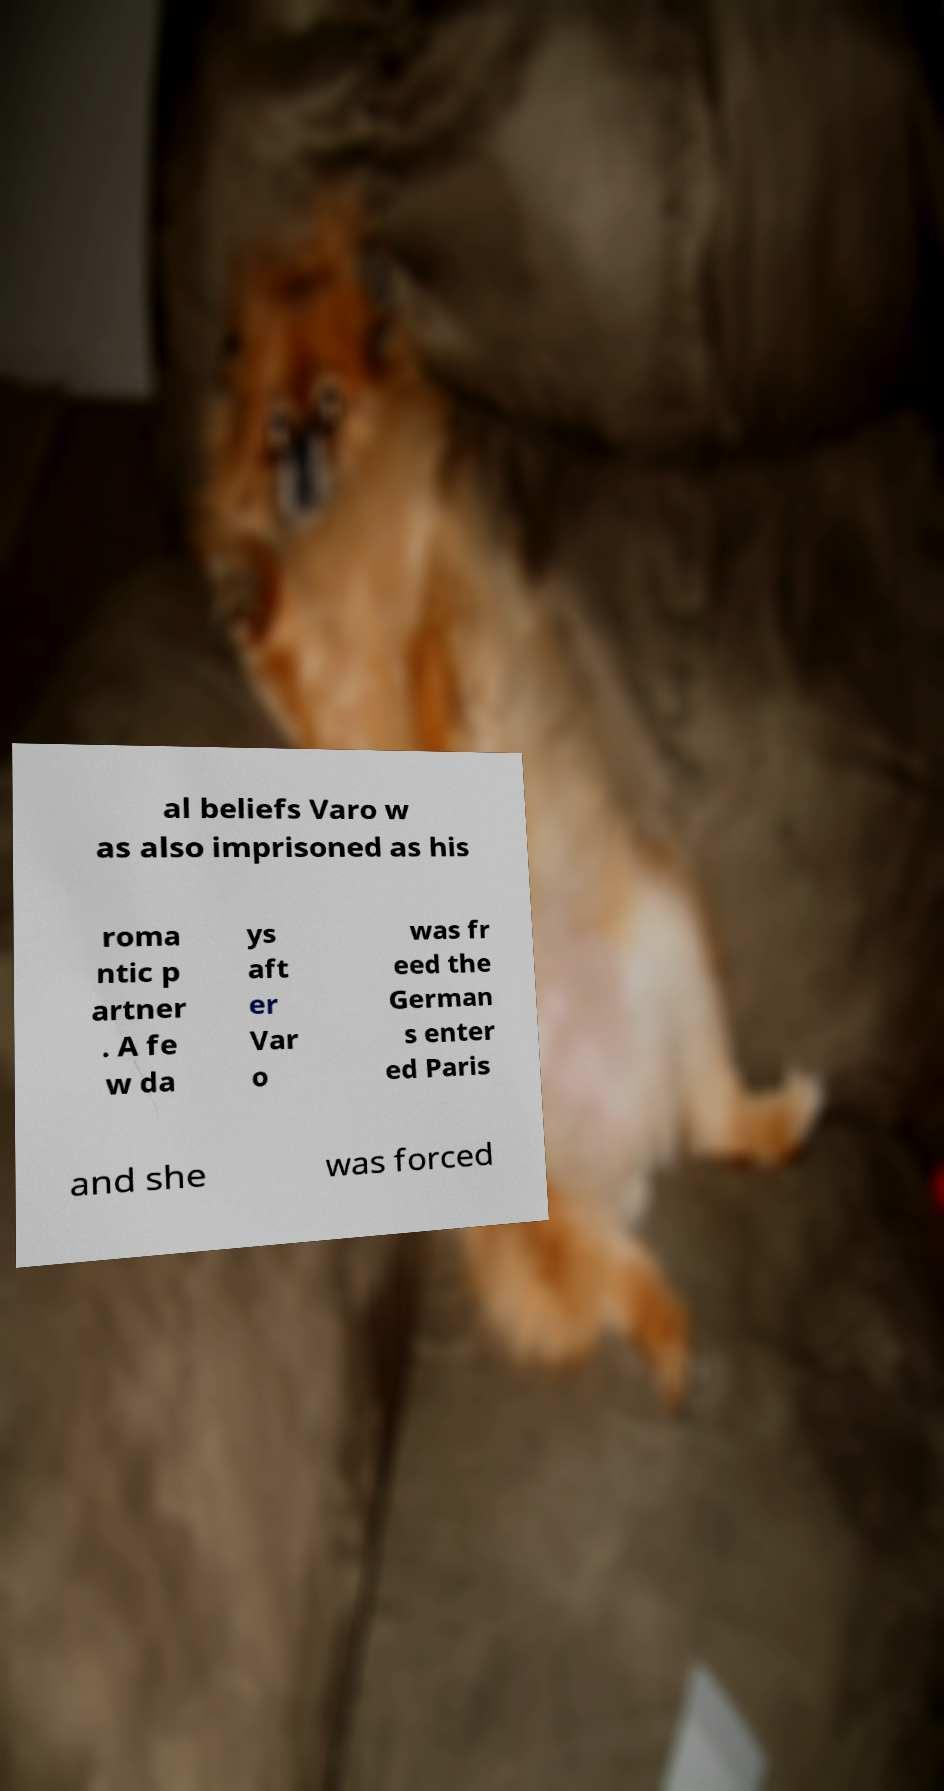For documentation purposes, I need the text within this image transcribed. Could you provide that? al beliefs Varo w as also imprisoned as his roma ntic p artner . A fe w da ys aft er Var o was fr eed the German s enter ed Paris and she was forced 